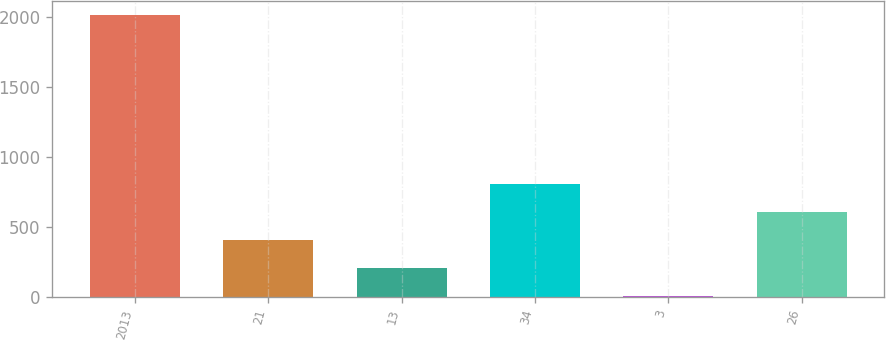Convert chart. <chart><loc_0><loc_0><loc_500><loc_500><bar_chart><fcel>2013<fcel>21<fcel>13<fcel>34<fcel>3<fcel>26<nl><fcel>2012<fcel>405.6<fcel>204.8<fcel>807.2<fcel>4<fcel>606.4<nl></chart> 